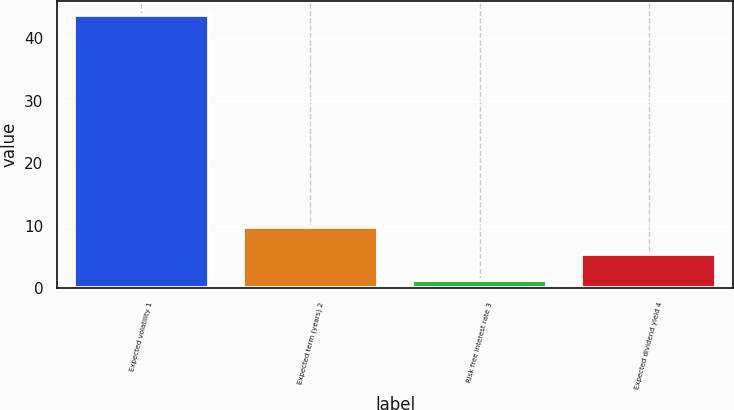<chart> <loc_0><loc_0><loc_500><loc_500><bar_chart><fcel>Expected volatility 1<fcel>Expected term (years) 2<fcel>Risk free interest rate 3<fcel>Expected dividend yield 4<nl><fcel>43.8<fcel>9.8<fcel>1.3<fcel>5.55<nl></chart> 